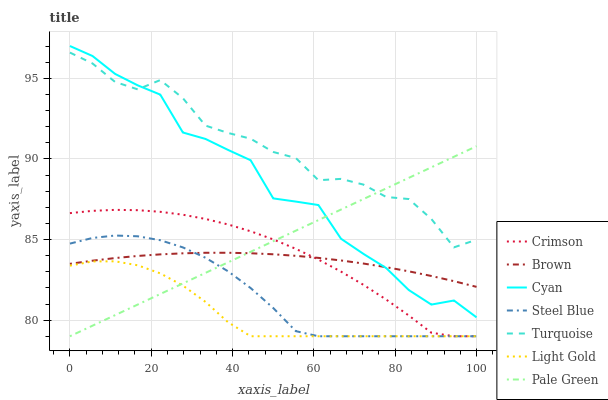Does Steel Blue have the minimum area under the curve?
Answer yes or no. No. Does Steel Blue have the maximum area under the curve?
Answer yes or no. No. Is Turquoise the smoothest?
Answer yes or no. No. Is Turquoise the roughest?
Answer yes or no. No. Does Turquoise have the lowest value?
Answer yes or no. No. Does Turquoise have the highest value?
Answer yes or no. No. Is Crimson less than Turquoise?
Answer yes or no. Yes. Is Cyan greater than Steel Blue?
Answer yes or no. Yes. Does Crimson intersect Turquoise?
Answer yes or no. No. 